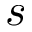<formula> <loc_0><loc_0><loc_500><loc_500>s</formula> 